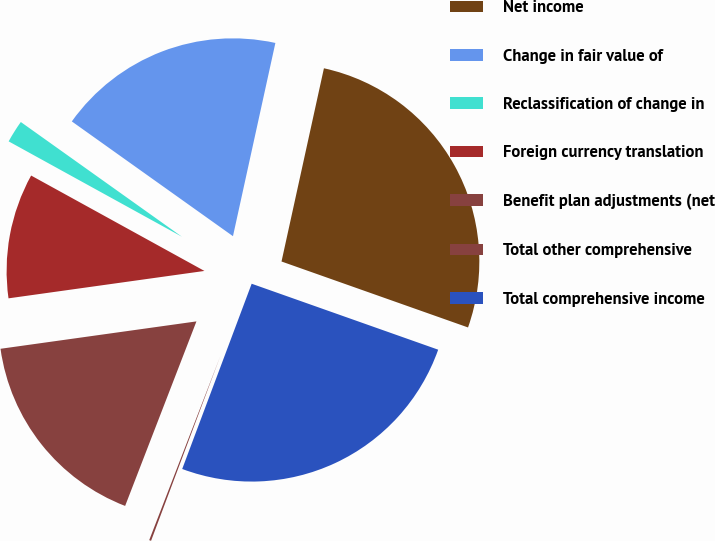Convert chart to OTSL. <chart><loc_0><loc_0><loc_500><loc_500><pie_chart><fcel>Net income<fcel>Change in fair value of<fcel>Reclassification of change in<fcel>Foreign currency translation<fcel>Benefit plan adjustments (net<fcel>Total other comprehensive<fcel>Total comprehensive income<nl><fcel>26.97%<fcel>18.59%<fcel>1.84%<fcel>10.22%<fcel>16.92%<fcel>0.16%<fcel>25.3%<nl></chart> 